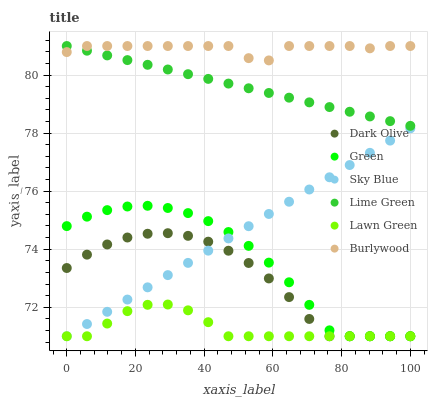Does Lawn Green have the minimum area under the curve?
Answer yes or no. Yes. Does Burlywood have the maximum area under the curve?
Answer yes or no. Yes. Does Dark Olive have the minimum area under the curve?
Answer yes or no. No. Does Dark Olive have the maximum area under the curve?
Answer yes or no. No. Is Lime Green the smoothest?
Answer yes or no. Yes. Is Burlywood the roughest?
Answer yes or no. Yes. Is Dark Olive the smoothest?
Answer yes or no. No. Is Dark Olive the roughest?
Answer yes or no. No. Does Lawn Green have the lowest value?
Answer yes or no. Yes. Does Burlywood have the lowest value?
Answer yes or no. No. Does Lime Green have the highest value?
Answer yes or no. Yes. Does Dark Olive have the highest value?
Answer yes or no. No. Is Dark Olive less than Lime Green?
Answer yes or no. Yes. Is Lime Green greater than Lawn Green?
Answer yes or no. Yes. Does Lime Green intersect Burlywood?
Answer yes or no. Yes. Is Lime Green less than Burlywood?
Answer yes or no. No. Is Lime Green greater than Burlywood?
Answer yes or no. No. Does Dark Olive intersect Lime Green?
Answer yes or no. No. 